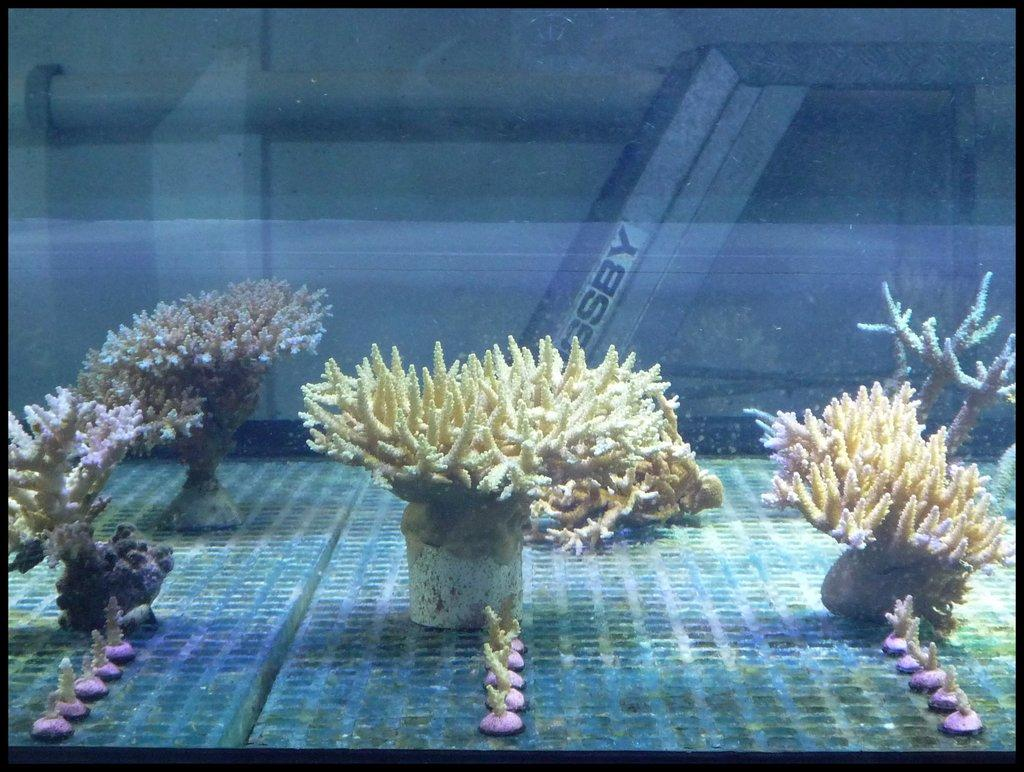What type of natural formation can be seen in the water in the image? There are corals in the water in the image. What can be seen in the background of the image? There is a pillar with text in the background of the image. How many slaves are visible in the image? There are no slaves present in the image. Are there any icicles hanging from the corals in the image? There are no icicles present in the image, as it features corals in water, which is not a typical environment for icicles. 